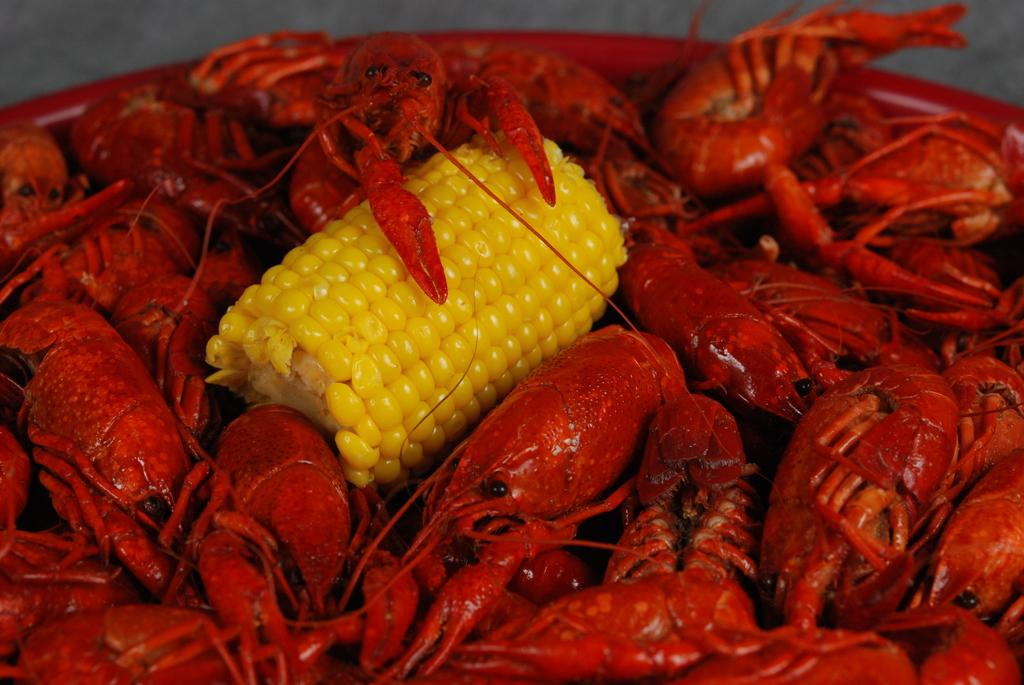What is the main subject in the center of the image? There is a corn in the center of the image. What other items are present in the image? There are red color prawns in the image. How are the corn and red color prawns arranged in the image? The corn is present in between the red color prawns. What type of song can be heard coming from the ladybug in the image? There is no ladybug present in the image, so it's not possible to determine what, if any, song might be heard. 